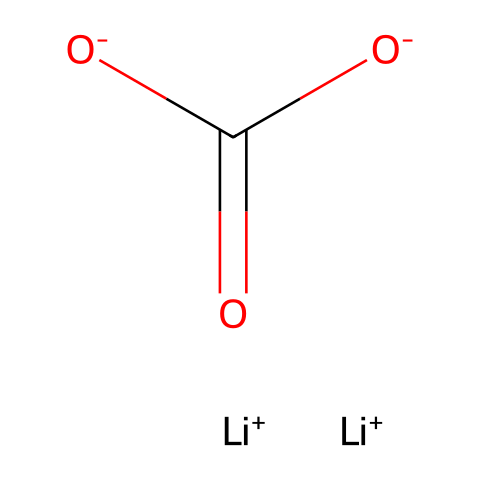What is the molecular formula of lithium carbonate? By analyzing the SMILES representation, we can count the number of each type of atom present. There are two lithium (Li) atoms, one carbon (C) atom, and three oxygen (O) atoms. Therefore, the molecular formula is derived from these counts.
Answer: Li2CO3 How many lithium atoms are present in the structure? The SMILES indicates that there are two instances of "Li+", which corresponds to the two lithium atoms present in the lithium carbonate structure.
Answer: 2 What type of bonding is observed in carbonates like lithium carbonate? The structural representation shows that the carbon atom is center-bound to the oxygen atoms, forming a carbonate group, which suggests covalent bonds are responsible for connecting the carbon and oxygen atoms, typical of carbonate bonding.
Answer: covalent Which atom has a formal negative charge in this structure? The SMILES representation includes "[O-]" before the carbon, revealing that one of the oxygen atoms carries a formal negative charge in this chemical structure.
Answer: oxygen What indicates that lithium carbonate is a salt? The presence of positively charged lithium ions (Li+) and negatively charged carbonate ions ([CO3]2-) in the SMILES structure signifies a classical ionic interaction, which is characteristic of salts.
Answer: ionic interaction How many oxygen atoms are directly bonded to the carbon in lithium carbonate? Observing the SMILES representation shows that the carbon atom is bonded to three oxygen atoms: two through single bonds and one through a double bond, requiring a simple count of those bonded directly to the carbon.
Answer: 3 What element contributes to the polyanionic character of lithium carbonate? The central carbonate unit comprises two negatively charged oxygen atoms and one doubly bonded oxygen to carbon, which creates an overall negative charge on the carbonate ion, indicating its polyanionic nature.
Answer: carbon 